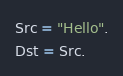<code> <loc_0><loc_0><loc_500><loc_500><_Erlang_>Src = "Hello".
Dst = Src.
</code> 